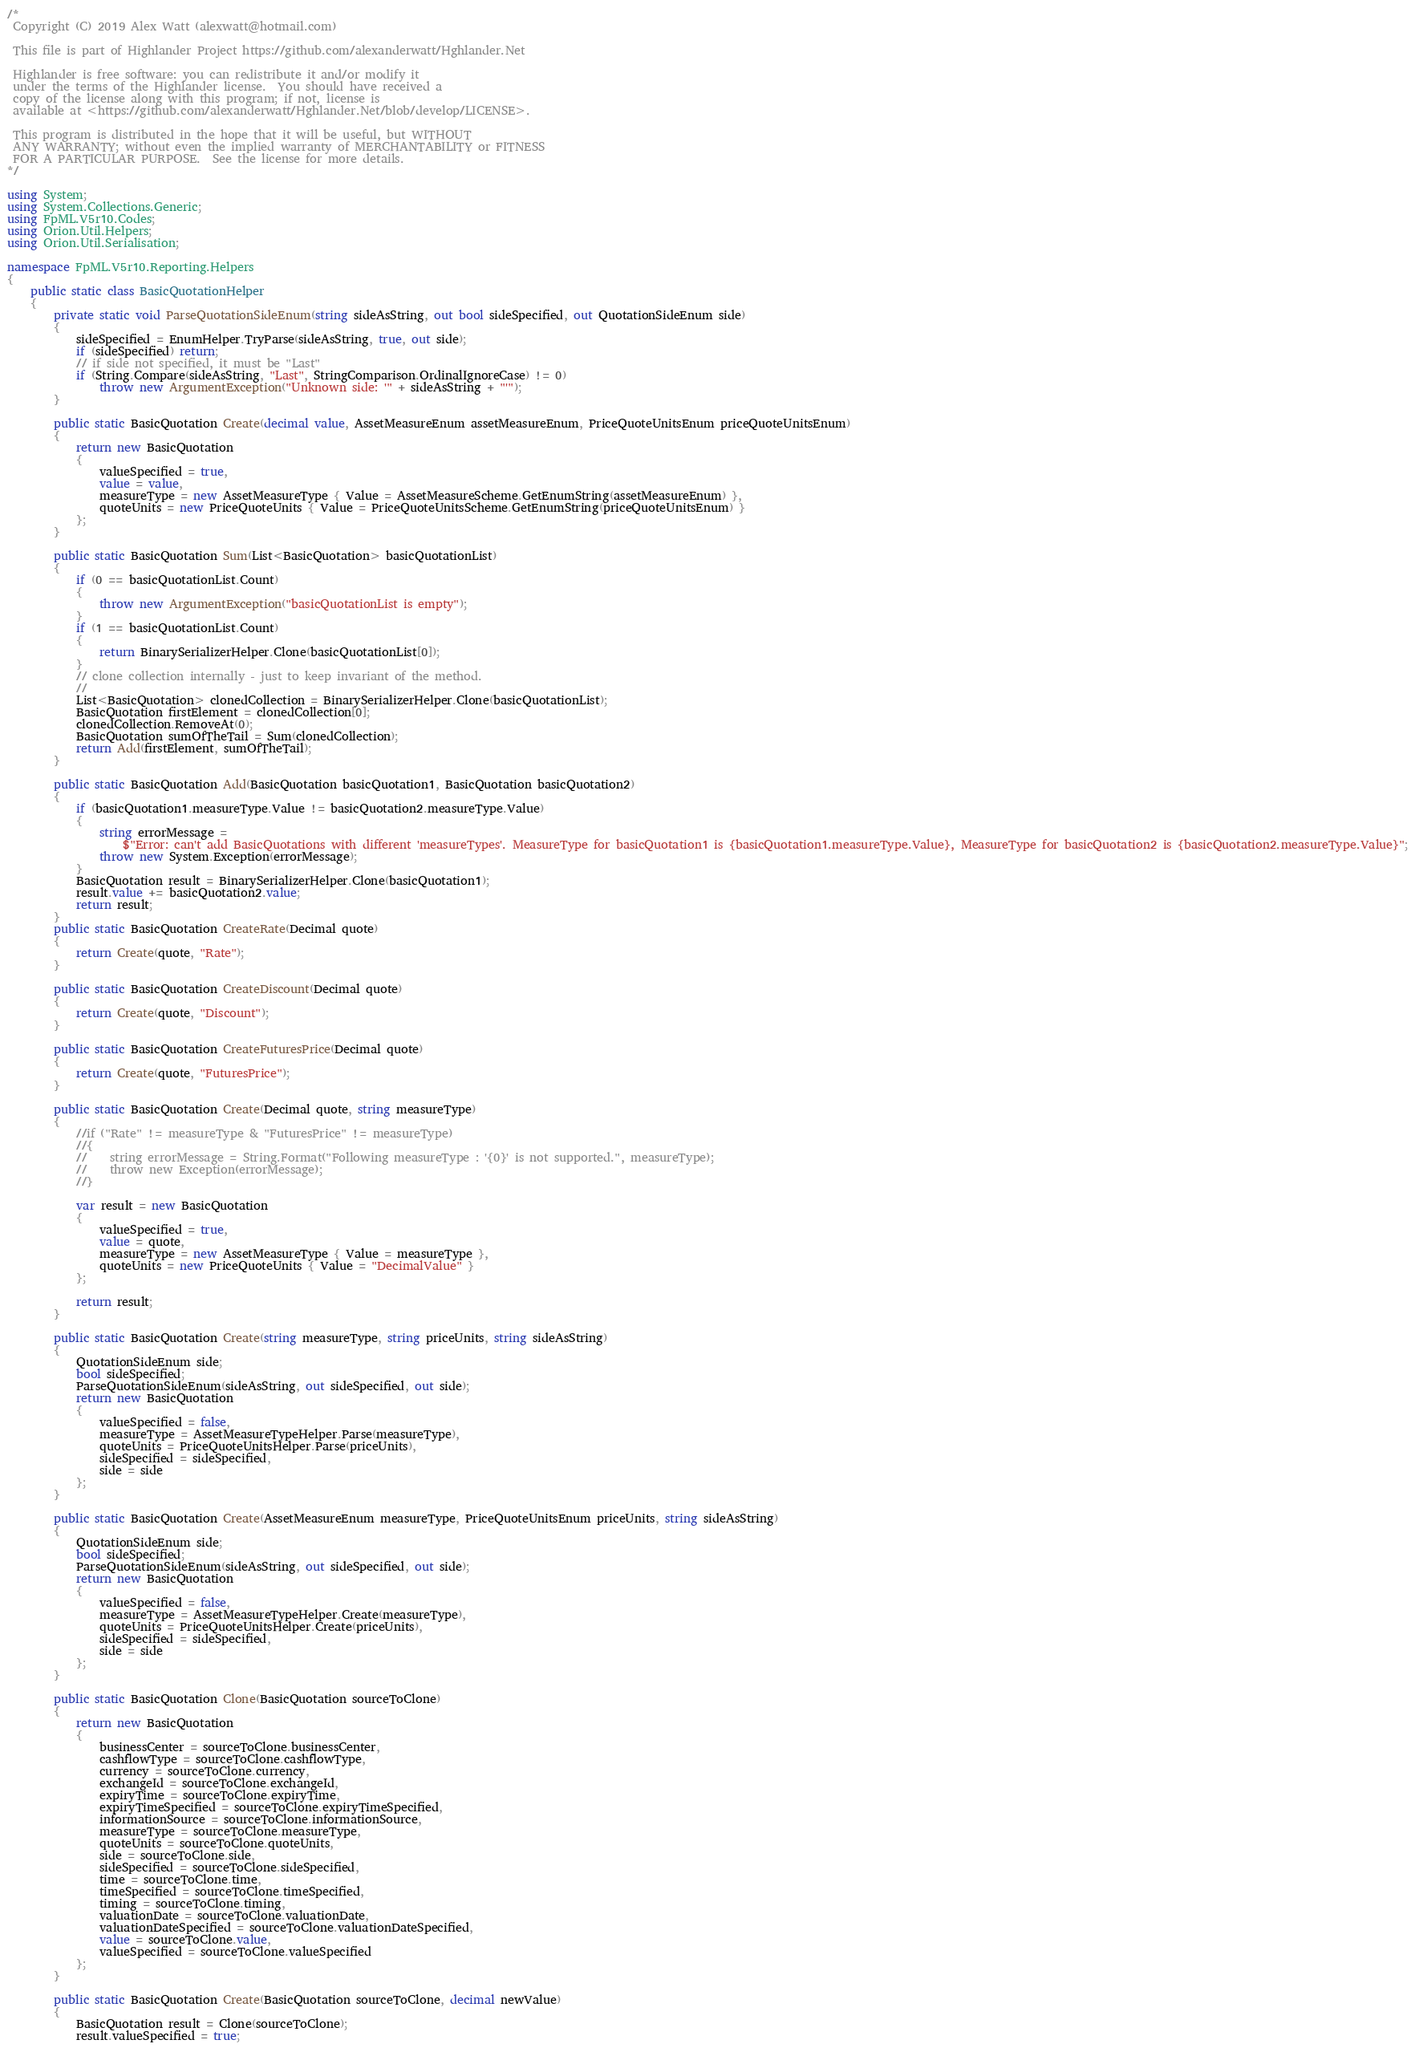Convert code to text. <code><loc_0><loc_0><loc_500><loc_500><_C#_>/*
 Copyright (C) 2019 Alex Watt (alexwatt@hotmail.com)

 This file is part of Highlander Project https://github.com/alexanderwatt/Hghlander.Net

 Highlander is free software: you can redistribute it and/or modify it
 under the terms of the Highlander license.  You should have received a
 copy of the license along with this program; if not, license is
 available at <https://github.com/alexanderwatt/Hghlander.Net/blob/develop/LICENSE>.

 This program is distributed in the hope that it will be useful, but WITHOUT
 ANY WARRANTY; without even the implied warranty of MERCHANTABILITY or FITNESS
 FOR A PARTICULAR PURPOSE.  See the license for more details.
*/

using System;
using System.Collections.Generic;
using FpML.V5r10.Codes;
using Orion.Util.Helpers;
using Orion.Util.Serialisation;

namespace FpML.V5r10.Reporting.Helpers
{
    public static class BasicQuotationHelper
    {
        private static void ParseQuotationSideEnum(string sideAsString, out bool sideSpecified, out QuotationSideEnum side)
        {
            sideSpecified = EnumHelper.TryParse(sideAsString, true, out side);
            if (sideSpecified) return;
            // if side not specified, it must be "Last"
            if (String.Compare(sideAsString, "Last", StringComparison.OrdinalIgnoreCase) != 0)
                throw new ArgumentException("Unknown side: '" + sideAsString + "'");
        }

        public static BasicQuotation Create(decimal value, AssetMeasureEnum assetMeasureEnum, PriceQuoteUnitsEnum priceQuoteUnitsEnum)
        {
            return new BasicQuotation
            {
                valueSpecified = true,
                value = value,
                measureType = new AssetMeasureType { Value = AssetMeasureScheme.GetEnumString(assetMeasureEnum) },
                quoteUnits = new PriceQuoteUnits { Value = PriceQuoteUnitsScheme.GetEnumString(priceQuoteUnitsEnum) }
            };
        }

        public static BasicQuotation Sum(List<BasicQuotation> basicQuotationList)
        {
            if (0 == basicQuotationList.Count)
            {
                throw new ArgumentException("basicQuotationList is empty");
            }
            if (1 == basicQuotationList.Count)
            {
                return BinarySerializerHelper.Clone(basicQuotationList[0]);
            }
            // clone collection internally - just to keep invariant of the method.
            //  
            List<BasicQuotation> clonedCollection = BinarySerializerHelper.Clone(basicQuotationList);
            BasicQuotation firstElement = clonedCollection[0];
            clonedCollection.RemoveAt(0);
            BasicQuotation sumOfTheTail = Sum(clonedCollection);
            return Add(firstElement, sumOfTheTail);
        }

        public static BasicQuotation Add(BasicQuotation basicQuotation1, BasicQuotation basicQuotation2)
        {
            if (basicQuotation1.measureType.Value != basicQuotation2.measureType.Value)
            {
                string errorMessage =
                    $"Error: can't add BasicQuotations with different 'measureTypes'. MeasureType for basicQuotation1 is {basicQuotation1.measureType.Value}, MeasureType for basicQuotation2 is {basicQuotation2.measureType.Value}";
                throw new System.Exception(errorMessage);
            }
            BasicQuotation result = BinarySerializerHelper.Clone(basicQuotation1);
            result.value += basicQuotation2.value;
            return result;
        }
        public static BasicQuotation CreateRate(Decimal quote)
        {
            return Create(quote, "Rate");
        }

        public static BasicQuotation CreateDiscount(Decimal quote)
        {
            return Create(quote, "Discount");
        }

        public static BasicQuotation CreateFuturesPrice(Decimal quote)
        {
            return Create(quote, "FuturesPrice");
        }

        public static BasicQuotation Create(Decimal quote, string measureType)
        {
            //if ("Rate" != measureType & "FuturesPrice" != measureType)
            //{
            //    string errorMessage = String.Format("Following measureType : '{0}' is not supported.", measureType);
            //    throw new Exception(errorMessage);
            //}

            var result = new BasicQuotation
            {
                valueSpecified = true,
                value = quote,
                measureType = new AssetMeasureType { Value = measureType },
                quoteUnits = new PriceQuoteUnits { Value = "DecimalValue" }
            };

            return result;
        }

        public static BasicQuotation Create(string measureType, string priceUnits, string sideAsString)
        {
            QuotationSideEnum side;
            bool sideSpecified;
            ParseQuotationSideEnum(sideAsString, out sideSpecified, out side);
            return new BasicQuotation
            {
                valueSpecified = false,
                measureType = AssetMeasureTypeHelper.Parse(measureType),
                quoteUnits = PriceQuoteUnitsHelper.Parse(priceUnits),
                sideSpecified = sideSpecified,
                side = side
            };
        }

        public static BasicQuotation Create(AssetMeasureEnum measureType, PriceQuoteUnitsEnum priceUnits, string sideAsString)
        {
            QuotationSideEnum side;
            bool sideSpecified;
            ParseQuotationSideEnum(sideAsString, out sideSpecified, out side);
            return new BasicQuotation
            {
                valueSpecified = false,
                measureType = AssetMeasureTypeHelper.Create(measureType),
                quoteUnits = PriceQuoteUnitsHelper.Create(priceUnits),
                sideSpecified = sideSpecified,
                side = side
            };
        }

        public static BasicQuotation Clone(BasicQuotation sourceToClone)
        {
            return new BasicQuotation
            {
                businessCenter = sourceToClone.businessCenter,
                cashflowType = sourceToClone.cashflowType,
                currency = sourceToClone.currency,
                exchangeId = sourceToClone.exchangeId,
                expiryTime = sourceToClone.expiryTime,
                expiryTimeSpecified = sourceToClone.expiryTimeSpecified,
                informationSource = sourceToClone.informationSource,
                measureType = sourceToClone.measureType,
                quoteUnits = sourceToClone.quoteUnits,
                side = sourceToClone.side,
                sideSpecified = sourceToClone.sideSpecified,
                time = sourceToClone.time,
                timeSpecified = sourceToClone.timeSpecified,
                timing = sourceToClone.timing,
                valuationDate = sourceToClone.valuationDate,
                valuationDateSpecified = sourceToClone.valuationDateSpecified,
                value = sourceToClone.value,
                valueSpecified = sourceToClone.valueSpecified
            };
        }

        public static BasicQuotation Create(BasicQuotation sourceToClone, decimal newValue)
        {
            BasicQuotation result = Clone(sourceToClone);
            result.valueSpecified = true;</code> 